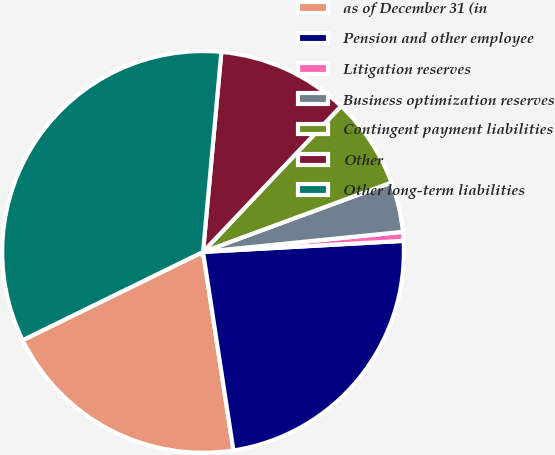Convert chart. <chart><loc_0><loc_0><loc_500><loc_500><pie_chart><fcel>as of December 31 (in<fcel>Pension and other employee<fcel>Litigation reserves<fcel>Business optimization reserves<fcel>Contingent payment liabilities<fcel>Other<fcel>Other long-term liabilities<nl><fcel>20.17%<fcel>23.46%<fcel>0.72%<fcel>4.02%<fcel>7.32%<fcel>10.61%<fcel>33.7%<nl></chart> 